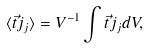Convert formula to latex. <formula><loc_0><loc_0><loc_500><loc_500>\langle \vec { t } { j } _ { j } \rangle = V ^ { - 1 } \int \vec { t } { j } _ { j } d V ,</formula> 